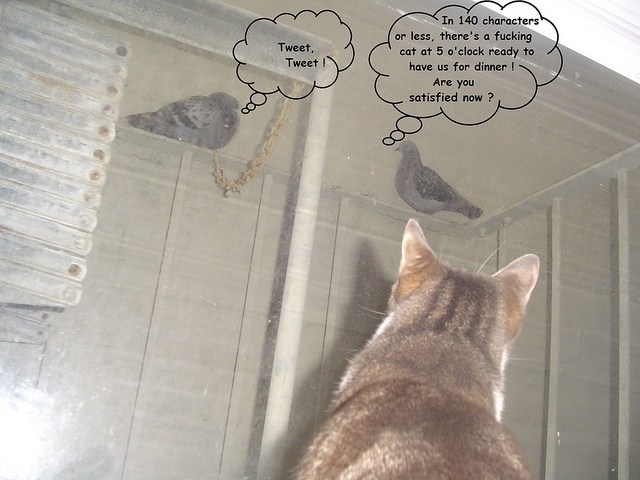Describe the objects in this image and their specific colors. I can see cat in gray and darkgray tones, bird in gray tones, and bird in gray tones in this image. 